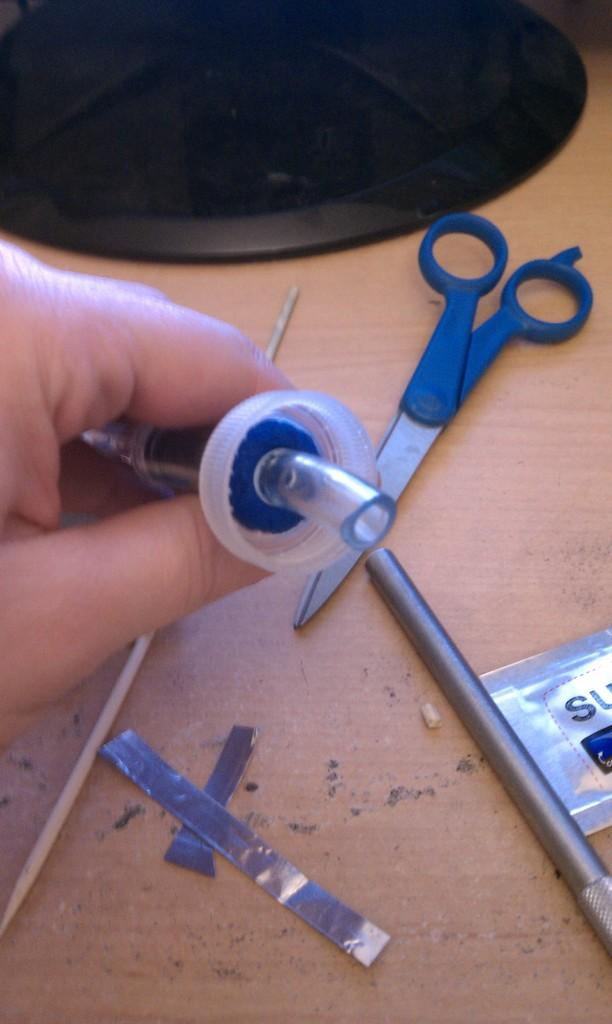What can be seen in the hand of the person in the image? There is an object in the hand of the person in the image. What is the surface that the hand and other objects are placed on? There is a wooden surface in the image. What tools are present on the wooden surface? There are scissors and a stick on the wooden surface. What type of adhesive material is present on the wooden surface? There is tape on the wooden surface. What other items can be seen on the wooden surface? There are other items on the wooden surface. Can you hear the owl hooting in the image? There is no owl present in the image, so it cannot be heard hooting. 